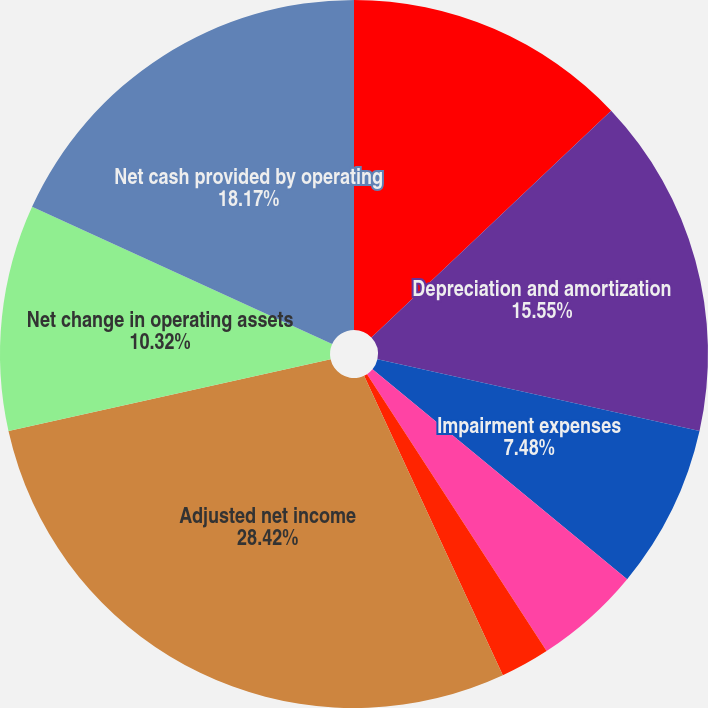Convert chart to OTSL. <chart><loc_0><loc_0><loc_500><loc_500><pie_chart><fcel>Net Income<fcel>Depreciation and amortization<fcel>Impairment expenses<fcel>Loss on the extinguishment of<fcel>Other adjustments to net<fcel>Adjusted net income<fcel>Net change in operating assets<fcel>Net cash provided by operating<nl><fcel>12.94%<fcel>15.55%<fcel>7.48%<fcel>4.87%<fcel>2.25%<fcel>28.41%<fcel>10.32%<fcel>18.17%<nl></chart> 